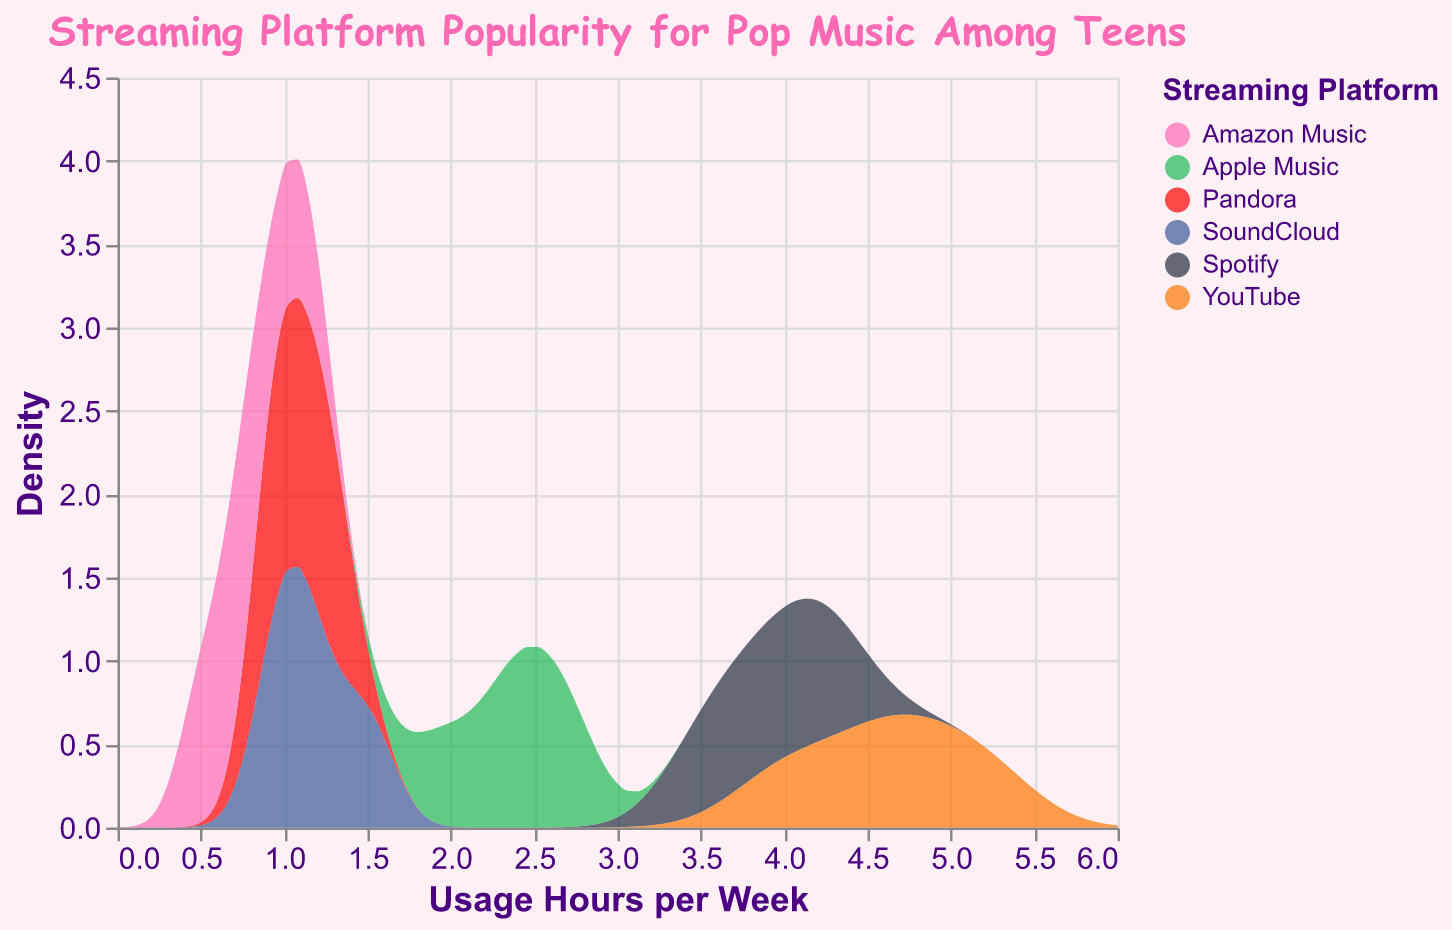What is the title of the density plot? The title of the density plot can be found at the top center of the visual. It clearly states the content or topic of the plot.
Answer: Streaming Platform Popularity for Pop Music Among Teens What does the x-axis represent? The x-axis in a density plot typically shows the variable for which the density is being estimated. Looking closely, the x-axis title is provided in the plot.
Answer: Usage Hours per Week Which color represents YouTube in the figure? Each platform is represented by a different color in the legend. By matching the platform name with the color, one determines the representation.
Answer: Red Which platform appears to have the highest peak in usage hours per week? By examining the density peaks of each platform's curve, we can identify the one with the highest peak.
Answer: YouTube What is the approximate range of usage hours per week for Amazon Music based on the density plot? The density plot shows the spread of usage hours for each platform. By observing where Amazon Music's density plot starts and ends, we get the range.
Answer: 0.5 to 1.1 hours Which platform has the most consistent (narrow spread) usage hours? To find the most consistent usage, look for the platform with the narrowest density spread along the x-axis.
Answer: Pandora How does the density of Spotify compare to that of Apple Music? Comparing the density curves of both platforms, look at the shape, spread, and peak usage hours to form a comparative analysis.
Answer: Spotify has higher density peaks and a slightly wider spread compared to Apple Music What can you say about the usage hours per week for SoundCloud among teens? Look at the density curve of SoundCloud to determine its central tendency and spread.
Answer: SoundCloud has moderate density with usage hours mostly ranging between 1.0 and 1.5 Between Pandora and Amazon Music, which one shows a higher density for usage hours around 1 hour per week? Compare the density values around the 1 hour mark for both Pandora and Amazon Music to identify which has a higher density at that point.
Answer: Pandora 